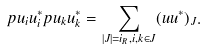<formula> <loc_0><loc_0><loc_500><loc_500>p u _ { i } u _ { i } ^ { * } p u _ { k } u _ { k } ^ { * } = \sum _ { | J | = i _ { R } , i , k \in J } ( u u ^ { * } ) _ { J } .</formula> 